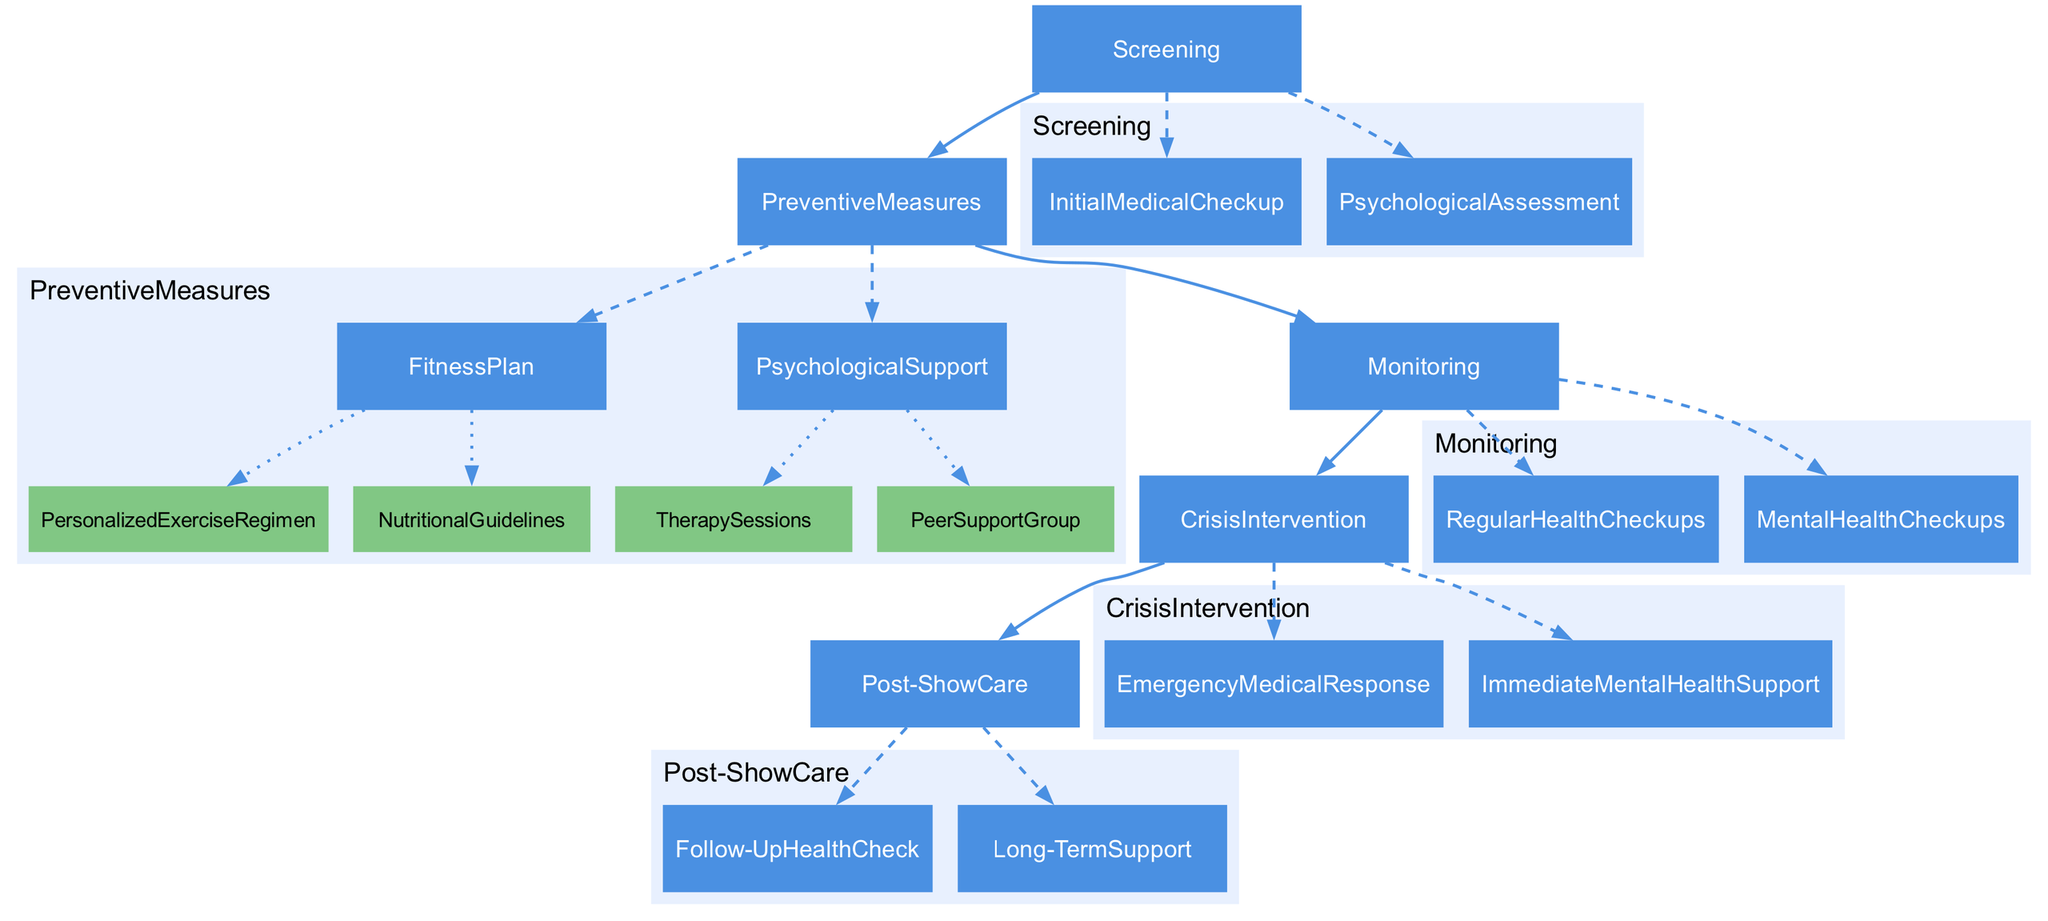What are the two main categories in the Clinical Pathway? The diagram presents two main categories: "Preventive Measures" and "Monitoring". These represent the critical focus areas for health management of reality TV show participants.
Answer: Preventive Measures, Monitoring How many subcategories are under the "Preventive Measures"? The subcategories under "Preventive Measures" are "Fitness Plan" and "Psychological Support". Therefore, there are two distinct subcategories.
Answer: 2 What is included in the "Initial Medical Checkup"? The "Initial Medical Checkup" includes a comprehensive physical exam that covers cardiovascular health, musculoskeletal condition, and metabolic screening.
Answer: Comprehensive physical exam covering cardiovascular health, musculoskeletal condition, and metabolic screening Which service is provided on a monthly basis? "Regular Health Checkups" are provided on a monthly basis to monitor participants' overall health status consistently.
Answer: Regular Health Checkups How often are "Therapy Sessions" conducted? "Therapy Sessions" are conducted weekly. This indicates a structured approach to mental health support for participants throughout their engagement in the show.
Answer: Weekly What is the purpose of "Emergency Medical Response"? "Emergency Medical Response" refers to the on-site medical team available 24/7, ensuring immediate attention to any emergent health issues that participants may face.
Answer: On-site medical team available 24/7 for any emergent health issues What type of evaluations occur bi-weekly? "Mental Health Checkups" occur bi-weekly, which ensures participants receive frequent evaluations and support for their psychological well-being during the show.
Answer: Bi-weekly mental health evaluations What is the nature of "Follow-Up Health Check"? The "Follow-Up Health Check" is a comprehensive health checkup one month post-show, aimed at ensuring continued well-being for the participants after their reality TV experience.
Answer: Comprehensive health checkup one month post-show to ensure continued well-being What kind of group meeting is included in Psychological Support? In Psychological Support, there is a "Peer Support Group" that involves regular group meetings to provide emotional support and share experiences among participants.
Answer: Peer Support Group 